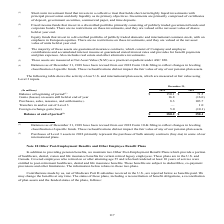According to Sealed Air Corporation's financial document, What does this table represent? The following table shows the activity of our U.S. and international plan assets, which are measured at fair value using Level 3 inputs.. The document states: "The following table shows the activity of our U.S. and international plan assets, which are measured at fair value using Level 3 inputs...." Also, Did revising of Balances as of December 31, 2018  from our 2018 Form 10-K filing to reflect changes in leveling classification of specific funds have an impact on the fair value of any of the pension plan assets? These reclassifications did not impact the fair value of any of our pension plan assets.. The document states: "nges in leveling classification of specific funds. These reclassifications did not impact the fair value of any of our pension plan assets...." Also, What years are included in the table? The document shows two values: 2019 and 2018. From the document: "(In millions) 2019 2018 (In millions) 2019 2018..." Also, can you calculate: What is the Balance at beginning of period expressed as a percentage of Balance at end of period for year 2019? Based on the calculation: 150.1/180.2, the result is 83.3 (percentage). This is based on the information: "Balance at beginning of period (1) $ 150.1 $ 71.5 (loss) 5.0 (10.1) Balance at end of period (1) $ 180.2 $ 150.1..." The key data points involved are: 150.1, 180.2. Also, can you calculate: What is the difference between the Balance at end of period for 2018 and 2019? Based on the calculation: 180.2-150.1, the result is 30.1 (in millions). This is based on the information: "Balance at beginning of period (1) $ 150.1 $ 71.5 (loss) 5.0 (10.1) Balance at end of period (1) $ 180.2 $ 150.1..." The key data points involved are: 150.1, 180.2. Also, can you calculate: What is percentage growth of Balance at end of period for year 2018 to 2019? To answer this question, I need to perform calculations using the financial data. The calculation is: (180.2-150.1)/150.1, which equals 20.05 (percentage). This is based on the information: "Balance at beginning of period (1) $ 150.1 $ 71.5 (loss) 5.0 (10.1) Balance at end of period (1) $ 180.2 $ 150.1..." The key data points involved are: 150.1, 180.2. 